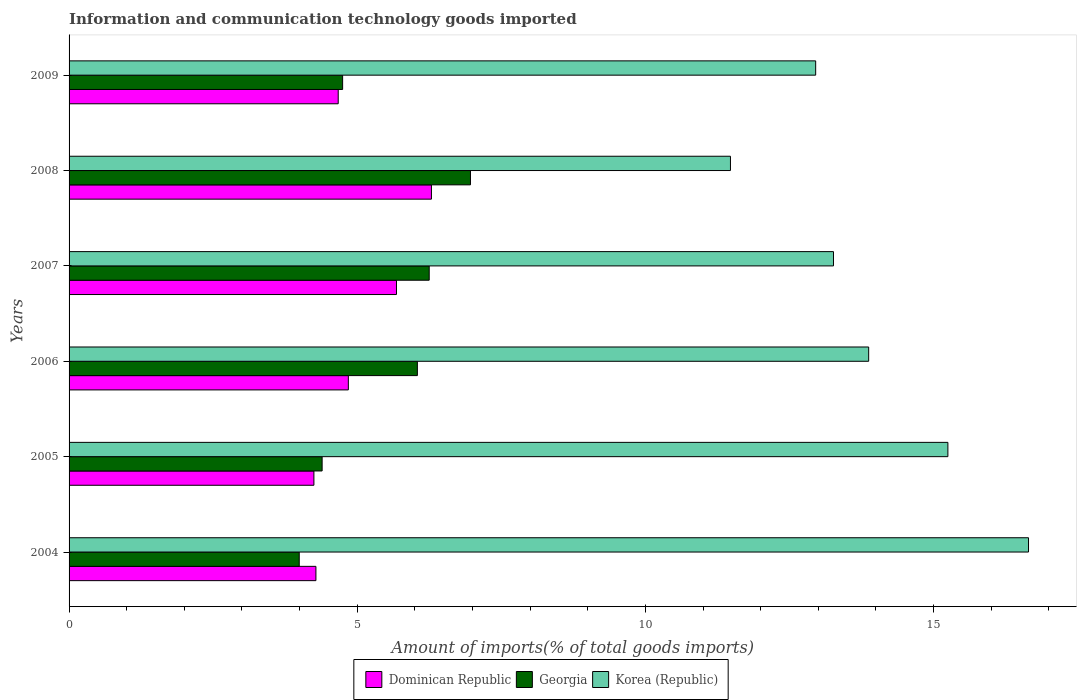How many groups of bars are there?
Ensure brevity in your answer.  6. Are the number of bars per tick equal to the number of legend labels?
Provide a short and direct response. Yes. What is the label of the 5th group of bars from the top?
Your answer should be compact. 2005. In how many cases, is the number of bars for a given year not equal to the number of legend labels?
Your answer should be very brief. 0. What is the amount of goods imported in Dominican Republic in 2005?
Provide a short and direct response. 4.25. Across all years, what is the maximum amount of goods imported in Korea (Republic)?
Give a very brief answer. 16.65. Across all years, what is the minimum amount of goods imported in Dominican Republic?
Give a very brief answer. 4.25. In which year was the amount of goods imported in Korea (Republic) maximum?
Give a very brief answer. 2004. In which year was the amount of goods imported in Dominican Republic minimum?
Ensure brevity in your answer.  2005. What is the total amount of goods imported in Korea (Republic) in the graph?
Ensure brevity in your answer.  83.47. What is the difference between the amount of goods imported in Georgia in 2006 and that in 2008?
Offer a very short reply. -0.92. What is the difference between the amount of goods imported in Dominican Republic in 2004 and the amount of goods imported in Korea (Republic) in 2008?
Make the answer very short. -7.19. What is the average amount of goods imported in Dominican Republic per year?
Offer a very short reply. 5. In the year 2008, what is the difference between the amount of goods imported in Korea (Republic) and amount of goods imported in Georgia?
Make the answer very short. 4.51. In how many years, is the amount of goods imported in Korea (Republic) greater than 10 %?
Your response must be concise. 6. What is the ratio of the amount of goods imported in Georgia in 2005 to that in 2007?
Give a very brief answer. 0.7. Is the amount of goods imported in Georgia in 2006 less than that in 2007?
Offer a very short reply. Yes. What is the difference between the highest and the second highest amount of goods imported in Dominican Republic?
Keep it short and to the point. 0.61. What is the difference between the highest and the lowest amount of goods imported in Dominican Republic?
Make the answer very short. 2.04. What does the 3rd bar from the top in 2008 represents?
Provide a succinct answer. Dominican Republic. Is it the case that in every year, the sum of the amount of goods imported in Georgia and amount of goods imported in Korea (Republic) is greater than the amount of goods imported in Dominican Republic?
Provide a short and direct response. Yes. How many bars are there?
Keep it short and to the point. 18. Are the values on the major ticks of X-axis written in scientific E-notation?
Offer a terse response. No. Does the graph contain any zero values?
Keep it short and to the point. No. Does the graph contain grids?
Give a very brief answer. No. Where does the legend appear in the graph?
Your answer should be very brief. Bottom center. How many legend labels are there?
Ensure brevity in your answer.  3. How are the legend labels stacked?
Give a very brief answer. Horizontal. What is the title of the graph?
Ensure brevity in your answer.  Information and communication technology goods imported. Does "Macao" appear as one of the legend labels in the graph?
Give a very brief answer. No. What is the label or title of the X-axis?
Your answer should be compact. Amount of imports(% of total goods imports). What is the label or title of the Y-axis?
Offer a very short reply. Years. What is the Amount of imports(% of total goods imports) in Dominican Republic in 2004?
Provide a short and direct response. 4.28. What is the Amount of imports(% of total goods imports) of Georgia in 2004?
Offer a terse response. 3.99. What is the Amount of imports(% of total goods imports) of Korea (Republic) in 2004?
Your answer should be very brief. 16.65. What is the Amount of imports(% of total goods imports) of Dominican Republic in 2005?
Offer a very short reply. 4.25. What is the Amount of imports(% of total goods imports) in Georgia in 2005?
Ensure brevity in your answer.  4.39. What is the Amount of imports(% of total goods imports) in Korea (Republic) in 2005?
Make the answer very short. 15.25. What is the Amount of imports(% of total goods imports) in Dominican Republic in 2006?
Ensure brevity in your answer.  4.85. What is the Amount of imports(% of total goods imports) in Georgia in 2006?
Keep it short and to the point. 6.04. What is the Amount of imports(% of total goods imports) of Korea (Republic) in 2006?
Keep it short and to the point. 13.87. What is the Amount of imports(% of total goods imports) of Dominican Republic in 2007?
Keep it short and to the point. 5.68. What is the Amount of imports(% of total goods imports) in Georgia in 2007?
Keep it short and to the point. 6.25. What is the Amount of imports(% of total goods imports) in Korea (Republic) in 2007?
Your response must be concise. 13.26. What is the Amount of imports(% of total goods imports) of Dominican Republic in 2008?
Keep it short and to the point. 6.29. What is the Amount of imports(% of total goods imports) of Georgia in 2008?
Provide a succinct answer. 6.96. What is the Amount of imports(% of total goods imports) of Korea (Republic) in 2008?
Make the answer very short. 11.48. What is the Amount of imports(% of total goods imports) of Dominican Republic in 2009?
Provide a short and direct response. 4.67. What is the Amount of imports(% of total goods imports) of Georgia in 2009?
Provide a succinct answer. 4.75. What is the Amount of imports(% of total goods imports) of Korea (Republic) in 2009?
Give a very brief answer. 12.95. Across all years, what is the maximum Amount of imports(% of total goods imports) in Dominican Republic?
Your answer should be very brief. 6.29. Across all years, what is the maximum Amount of imports(% of total goods imports) in Georgia?
Keep it short and to the point. 6.96. Across all years, what is the maximum Amount of imports(% of total goods imports) in Korea (Republic)?
Your response must be concise. 16.65. Across all years, what is the minimum Amount of imports(% of total goods imports) in Dominican Republic?
Your answer should be very brief. 4.25. Across all years, what is the minimum Amount of imports(% of total goods imports) of Georgia?
Provide a succinct answer. 3.99. Across all years, what is the minimum Amount of imports(% of total goods imports) in Korea (Republic)?
Keep it short and to the point. 11.48. What is the total Amount of imports(% of total goods imports) of Dominican Republic in the graph?
Offer a terse response. 30.02. What is the total Amount of imports(% of total goods imports) in Georgia in the graph?
Offer a terse response. 32.39. What is the total Amount of imports(% of total goods imports) in Korea (Republic) in the graph?
Your answer should be very brief. 83.47. What is the difference between the Amount of imports(% of total goods imports) of Dominican Republic in 2004 and that in 2005?
Offer a very short reply. 0.04. What is the difference between the Amount of imports(% of total goods imports) of Georgia in 2004 and that in 2005?
Offer a very short reply. -0.4. What is the difference between the Amount of imports(% of total goods imports) of Korea (Republic) in 2004 and that in 2005?
Give a very brief answer. 1.4. What is the difference between the Amount of imports(% of total goods imports) in Dominican Republic in 2004 and that in 2006?
Give a very brief answer. -0.56. What is the difference between the Amount of imports(% of total goods imports) of Georgia in 2004 and that in 2006?
Offer a very short reply. -2.05. What is the difference between the Amount of imports(% of total goods imports) in Korea (Republic) in 2004 and that in 2006?
Provide a succinct answer. 2.77. What is the difference between the Amount of imports(% of total goods imports) of Dominican Republic in 2004 and that in 2007?
Make the answer very short. -1.4. What is the difference between the Amount of imports(% of total goods imports) in Georgia in 2004 and that in 2007?
Your answer should be very brief. -2.26. What is the difference between the Amount of imports(% of total goods imports) of Korea (Republic) in 2004 and that in 2007?
Keep it short and to the point. 3.38. What is the difference between the Amount of imports(% of total goods imports) of Dominican Republic in 2004 and that in 2008?
Give a very brief answer. -2. What is the difference between the Amount of imports(% of total goods imports) in Georgia in 2004 and that in 2008?
Your answer should be compact. -2.97. What is the difference between the Amount of imports(% of total goods imports) in Korea (Republic) in 2004 and that in 2008?
Make the answer very short. 5.17. What is the difference between the Amount of imports(% of total goods imports) in Dominican Republic in 2004 and that in 2009?
Provide a succinct answer. -0.39. What is the difference between the Amount of imports(% of total goods imports) in Georgia in 2004 and that in 2009?
Keep it short and to the point. -0.75. What is the difference between the Amount of imports(% of total goods imports) of Korea (Republic) in 2004 and that in 2009?
Keep it short and to the point. 3.69. What is the difference between the Amount of imports(% of total goods imports) of Dominican Republic in 2005 and that in 2006?
Your response must be concise. -0.6. What is the difference between the Amount of imports(% of total goods imports) of Georgia in 2005 and that in 2006?
Offer a very short reply. -1.65. What is the difference between the Amount of imports(% of total goods imports) of Korea (Republic) in 2005 and that in 2006?
Offer a terse response. 1.37. What is the difference between the Amount of imports(% of total goods imports) in Dominican Republic in 2005 and that in 2007?
Keep it short and to the point. -1.43. What is the difference between the Amount of imports(% of total goods imports) in Georgia in 2005 and that in 2007?
Your answer should be compact. -1.86. What is the difference between the Amount of imports(% of total goods imports) of Korea (Republic) in 2005 and that in 2007?
Your response must be concise. 1.99. What is the difference between the Amount of imports(% of total goods imports) of Dominican Republic in 2005 and that in 2008?
Give a very brief answer. -2.04. What is the difference between the Amount of imports(% of total goods imports) of Georgia in 2005 and that in 2008?
Your answer should be compact. -2.57. What is the difference between the Amount of imports(% of total goods imports) of Korea (Republic) in 2005 and that in 2008?
Your response must be concise. 3.77. What is the difference between the Amount of imports(% of total goods imports) of Dominican Republic in 2005 and that in 2009?
Keep it short and to the point. -0.42. What is the difference between the Amount of imports(% of total goods imports) in Georgia in 2005 and that in 2009?
Offer a terse response. -0.36. What is the difference between the Amount of imports(% of total goods imports) in Korea (Republic) in 2005 and that in 2009?
Provide a short and direct response. 2.29. What is the difference between the Amount of imports(% of total goods imports) of Dominican Republic in 2006 and that in 2007?
Your answer should be very brief. -0.84. What is the difference between the Amount of imports(% of total goods imports) of Georgia in 2006 and that in 2007?
Give a very brief answer. -0.21. What is the difference between the Amount of imports(% of total goods imports) in Korea (Republic) in 2006 and that in 2007?
Offer a terse response. 0.61. What is the difference between the Amount of imports(% of total goods imports) of Dominican Republic in 2006 and that in 2008?
Make the answer very short. -1.44. What is the difference between the Amount of imports(% of total goods imports) in Georgia in 2006 and that in 2008?
Make the answer very short. -0.92. What is the difference between the Amount of imports(% of total goods imports) of Korea (Republic) in 2006 and that in 2008?
Offer a very short reply. 2.4. What is the difference between the Amount of imports(% of total goods imports) in Dominican Republic in 2006 and that in 2009?
Your response must be concise. 0.18. What is the difference between the Amount of imports(% of total goods imports) of Georgia in 2006 and that in 2009?
Give a very brief answer. 1.3. What is the difference between the Amount of imports(% of total goods imports) in Korea (Republic) in 2006 and that in 2009?
Your response must be concise. 0.92. What is the difference between the Amount of imports(% of total goods imports) of Dominican Republic in 2007 and that in 2008?
Offer a very short reply. -0.61. What is the difference between the Amount of imports(% of total goods imports) in Georgia in 2007 and that in 2008?
Provide a short and direct response. -0.72. What is the difference between the Amount of imports(% of total goods imports) of Korea (Republic) in 2007 and that in 2008?
Give a very brief answer. 1.79. What is the difference between the Amount of imports(% of total goods imports) of Dominican Republic in 2007 and that in 2009?
Your answer should be very brief. 1.01. What is the difference between the Amount of imports(% of total goods imports) in Georgia in 2007 and that in 2009?
Provide a succinct answer. 1.5. What is the difference between the Amount of imports(% of total goods imports) in Korea (Republic) in 2007 and that in 2009?
Offer a terse response. 0.31. What is the difference between the Amount of imports(% of total goods imports) in Dominican Republic in 2008 and that in 2009?
Your response must be concise. 1.62. What is the difference between the Amount of imports(% of total goods imports) of Georgia in 2008 and that in 2009?
Give a very brief answer. 2.22. What is the difference between the Amount of imports(% of total goods imports) of Korea (Republic) in 2008 and that in 2009?
Ensure brevity in your answer.  -1.48. What is the difference between the Amount of imports(% of total goods imports) of Dominican Republic in 2004 and the Amount of imports(% of total goods imports) of Georgia in 2005?
Provide a succinct answer. -0.11. What is the difference between the Amount of imports(% of total goods imports) of Dominican Republic in 2004 and the Amount of imports(% of total goods imports) of Korea (Republic) in 2005?
Your response must be concise. -10.97. What is the difference between the Amount of imports(% of total goods imports) in Georgia in 2004 and the Amount of imports(% of total goods imports) in Korea (Republic) in 2005?
Make the answer very short. -11.26. What is the difference between the Amount of imports(% of total goods imports) of Dominican Republic in 2004 and the Amount of imports(% of total goods imports) of Georgia in 2006?
Offer a very short reply. -1.76. What is the difference between the Amount of imports(% of total goods imports) of Dominican Republic in 2004 and the Amount of imports(% of total goods imports) of Korea (Republic) in 2006?
Offer a very short reply. -9.59. What is the difference between the Amount of imports(% of total goods imports) in Georgia in 2004 and the Amount of imports(% of total goods imports) in Korea (Republic) in 2006?
Make the answer very short. -9.88. What is the difference between the Amount of imports(% of total goods imports) of Dominican Republic in 2004 and the Amount of imports(% of total goods imports) of Georgia in 2007?
Make the answer very short. -1.97. What is the difference between the Amount of imports(% of total goods imports) in Dominican Republic in 2004 and the Amount of imports(% of total goods imports) in Korea (Republic) in 2007?
Offer a very short reply. -8.98. What is the difference between the Amount of imports(% of total goods imports) in Georgia in 2004 and the Amount of imports(% of total goods imports) in Korea (Republic) in 2007?
Your response must be concise. -9.27. What is the difference between the Amount of imports(% of total goods imports) of Dominican Republic in 2004 and the Amount of imports(% of total goods imports) of Georgia in 2008?
Your answer should be very brief. -2.68. What is the difference between the Amount of imports(% of total goods imports) of Dominican Republic in 2004 and the Amount of imports(% of total goods imports) of Korea (Republic) in 2008?
Ensure brevity in your answer.  -7.19. What is the difference between the Amount of imports(% of total goods imports) in Georgia in 2004 and the Amount of imports(% of total goods imports) in Korea (Republic) in 2008?
Provide a succinct answer. -7.48. What is the difference between the Amount of imports(% of total goods imports) of Dominican Republic in 2004 and the Amount of imports(% of total goods imports) of Georgia in 2009?
Make the answer very short. -0.46. What is the difference between the Amount of imports(% of total goods imports) of Dominican Republic in 2004 and the Amount of imports(% of total goods imports) of Korea (Republic) in 2009?
Make the answer very short. -8.67. What is the difference between the Amount of imports(% of total goods imports) in Georgia in 2004 and the Amount of imports(% of total goods imports) in Korea (Republic) in 2009?
Keep it short and to the point. -8.96. What is the difference between the Amount of imports(% of total goods imports) of Dominican Republic in 2005 and the Amount of imports(% of total goods imports) of Georgia in 2006?
Ensure brevity in your answer.  -1.8. What is the difference between the Amount of imports(% of total goods imports) in Dominican Republic in 2005 and the Amount of imports(% of total goods imports) in Korea (Republic) in 2006?
Offer a terse response. -9.63. What is the difference between the Amount of imports(% of total goods imports) of Georgia in 2005 and the Amount of imports(% of total goods imports) of Korea (Republic) in 2006?
Offer a terse response. -9.48. What is the difference between the Amount of imports(% of total goods imports) in Dominican Republic in 2005 and the Amount of imports(% of total goods imports) in Georgia in 2007?
Offer a terse response. -2. What is the difference between the Amount of imports(% of total goods imports) of Dominican Republic in 2005 and the Amount of imports(% of total goods imports) of Korea (Republic) in 2007?
Offer a very short reply. -9.02. What is the difference between the Amount of imports(% of total goods imports) of Georgia in 2005 and the Amount of imports(% of total goods imports) of Korea (Republic) in 2007?
Your answer should be very brief. -8.87. What is the difference between the Amount of imports(% of total goods imports) in Dominican Republic in 2005 and the Amount of imports(% of total goods imports) in Georgia in 2008?
Your response must be concise. -2.72. What is the difference between the Amount of imports(% of total goods imports) of Dominican Republic in 2005 and the Amount of imports(% of total goods imports) of Korea (Republic) in 2008?
Your answer should be compact. -7.23. What is the difference between the Amount of imports(% of total goods imports) of Georgia in 2005 and the Amount of imports(% of total goods imports) of Korea (Republic) in 2008?
Offer a terse response. -7.09. What is the difference between the Amount of imports(% of total goods imports) of Dominican Republic in 2005 and the Amount of imports(% of total goods imports) of Georgia in 2009?
Make the answer very short. -0.5. What is the difference between the Amount of imports(% of total goods imports) in Dominican Republic in 2005 and the Amount of imports(% of total goods imports) in Korea (Republic) in 2009?
Your answer should be very brief. -8.71. What is the difference between the Amount of imports(% of total goods imports) in Georgia in 2005 and the Amount of imports(% of total goods imports) in Korea (Republic) in 2009?
Make the answer very short. -8.56. What is the difference between the Amount of imports(% of total goods imports) of Dominican Republic in 2006 and the Amount of imports(% of total goods imports) of Georgia in 2007?
Ensure brevity in your answer.  -1.4. What is the difference between the Amount of imports(% of total goods imports) of Dominican Republic in 2006 and the Amount of imports(% of total goods imports) of Korea (Republic) in 2007?
Offer a very short reply. -8.42. What is the difference between the Amount of imports(% of total goods imports) of Georgia in 2006 and the Amount of imports(% of total goods imports) of Korea (Republic) in 2007?
Ensure brevity in your answer.  -7.22. What is the difference between the Amount of imports(% of total goods imports) in Dominican Republic in 2006 and the Amount of imports(% of total goods imports) in Georgia in 2008?
Your answer should be compact. -2.12. What is the difference between the Amount of imports(% of total goods imports) of Dominican Republic in 2006 and the Amount of imports(% of total goods imports) of Korea (Republic) in 2008?
Your response must be concise. -6.63. What is the difference between the Amount of imports(% of total goods imports) of Georgia in 2006 and the Amount of imports(% of total goods imports) of Korea (Republic) in 2008?
Your answer should be compact. -5.43. What is the difference between the Amount of imports(% of total goods imports) in Dominican Republic in 2006 and the Amount of imports(% of total goods imports) in Georgia in 2009?
Keep it short and to the point. 0.1. What is the difference between the Amount of imports(% of total goods imports) in Dominican Republic in 2006 and the Amount of imports(% of total goods imports) in Korea (Republic) in 2009?
Your response must be concise. -8.11. What is the difference between the Amount of imports(% of total goods imports) in Georgia in 2006 and the Amount of imports(% of total goods imports) in Korea (Republic) in 2009?
Make the answer very short. -6.91. What is the difference between the Amount of imports(% of total goods imports) of Dominican Republic in 2007 and the Amount of imports(% of total goods imports) of Georgia in 2008?
Offer a very short reply. -1.28. What is the difference between the Amount of imports(% of total goods imports) of Dominican Republic in 2007 and the Amount of imports(% of total goods imports) of Korea (Republic) in 2008?
Give a very brief answer. -5.8. What is the difference between the Amount of imports(% of total goods imports) of Georgia in 2007 and the Amount of imports(% of total goods imports) of Korea (Republic) in 2008?
Offer a terse response. -5.23. What is the difference between the Amount of imports(% of total goods imports) of Dominican Republic in 2007 and the Amount of imports(% of total goods imports) of Georgia in 2009?
Keep it short and to the point. 0.93. What is the difference between the Amount of imports(% of total goods imports) in Dominican Republic in 2007 and the Amount of imports(% of total goods imports) in Korea (Republic) in 2009?
Make the answer very short. -7.27. What is the difference between the Amount of imports(% of total goods imports) of Georgia in 2007 and the Amount of imports(% of total goods imports) of Korea (Republic) in 2009?
Provide a succinct answer. -6.71. What is the difference between the Amount of imports(% of total goods imports) in Dominican Republic in 2008 and the Amount of imports(% of total goods imports) in Georgia in 2009?
Keep it short and to the point. 1.54. What is the difference between the Amount of imports(% of total goods imports) of Dominican Republic in 2008 and the Amount of imports(% of total goods imports) of Korea (Republic) in 2009?
Make the answer very short. -6.67. What is the difference between the Amount of imports(% of total goods imports) in Georgia in 2008 and the Amount of imports(% of total goods imports) in Korea (Republic) in 2009?
Provide a short and direct response. -5.99. What is the average Amount of imports(% of total goods imports) of Dominican Republic per year?
Ensure brevity in your answer.  5. What is the average Amount of imports(% of total goods imports) of Georgia per year?
Make the answer very short. 5.4. What is the average Amount of imports(% of total goods imports) of Korea (Republic) per year?
Make the answer very short. 13.91. In the year 2004, what is the difference between the Amount of imports(% of total goods imports) in Dominican Republic and Amount of imports(% of total goods imports) in Georgia?
Ensure brevity in your answer.  0.29. In the year 2004, what is the difference between the Amount of imports(% of total goods imports) of Dominican Republic and Amount of imports(% of total goods imports) of Korea (Republic)?
Offer a very short reply. -12.36. In the year 2004, what is the difference between the Amount of imports(% of total goods imports) of Georgia and Amount of imports(% of total goods imports) of Korea (Republic)?
Your response must be concise. -12.65. In the year 2005, what is the difference between the Amount of imports(% of total goods imports) in Dominican Republic and Amount of imports(% of total goods imports) in Georgia?
Make the answer very short. -0.14. In the year 2005, what is the difference between the Amount of imports(% of total goods imports) of Dominican Republic and Amount of imports(% of total goods imports) of Korea (Republic)?
Ensure brevity in your answer.  -11. In the year 2005, what is the difference between the Amount of imports(% of total goods imports) in Georgia and Amount of imports(% of total goods imports) in Korea (Republic)?
Your response must be concise. -10.86. In the year 2006, what is the difference between the Amount of imports(% of total goods imports) in Dominican Republic and Amount of imports(% of total goods imports) in Georgia?
Provide a short and direct response. -1.2. In the year 2006, what is the difference between the Amount of imports(% of total goods imports) in Dominican Republic and Amount of imports(% of total goods imports) in Korea (Republic)?
Your answer should be very brief. -9.03. In the year 2006, what is the difference between the Amount of imports(% of total goods imports) of Georgia and Amount of imports(% of total goods imports) of Korea (Republic)?
Ensure brevity in your answer.  -7.83. In the year 2007, what is the difference between the Amount of imports(% of total goods imports) in Dominican Republic and Amount of imports(% of total goods imports) in Georgia?
Offer a very short reply. -0.57. In the year 2007, what is the difference between the Amount of imports(% of total goods imports) in Dominican Republic and Amount of imports(% of total goods imports) in Korea (Republic)?
Make the answer very short. -7.58. In the year 2007, what is the difference between the Amount of imports(% of total goods imports) of Georgia and Amount of imports(% of total goods imports) of Korea (Republic)?
Ensure brevity in your answer.  -7.01. In the year 2008, what is the difference between the Amount of imports(% of total goods imports) of Dominican Republic and Amount of imports(% of total goods imports) of Georgia?
Ensure brevity in your answer.  -0.68. In the year 2008, what is the difference between the Amount of imports(% of total goods imports) in Dominican Republic and Amount of imports(% of total goods imports) in Korea (Republic)?
Provide a short and direct response. -5.19. In the year 2008, what is the difference between the Amount of imports(% of total goods imports) in Georgia and Amount of imports(% of total goods imports) in Korea (Republic)?
Give a very brief answer. -4.51. In the year 2009, what is the difference between the Amount of imports(% of total goods imports) of Dominican Republic and Amount of imports(% of total goods imports) of Georgia?
Your answer should be compact. -0.08. In the year 2009, what is the difference between the Amount of imports(% of total goods imports) of Dominican Republic and Amount of imports(% of total goods imports) of Korea (Republic)?
Provide a succinct answer. -8.28. In the year 2009, what is the difference between the Amount of imports(% of total goods imports) in Georgia and Amount of imports(% of total goods imports) in Korea (Republic)?
Keep it short and to the point. -8.21. What is the ratio of the Amount of imports(% of total goods imports) in Dominican Republic in 2004 to that in 2005?
Your response must be concise. 1.01. What is the ratio of the Amount of imports(% of total goods imports) in Georgia in 2004 to that in 2005?
Provide a succinct answer. 0.91. What is the ratio of the Amount of imports(% of total goods imports) in Korea (Republic) in 2004 to that in 2005?
Make the answer very short. 1.09. What is the ratio of the Amount of imports(% of total goods imports) of Dominican Republic in 2004 to that in 2006?
Your answer should be compact. 0.88. What is the ratio of the Amount of imports(% of total goods imports) in Georgia in 2004 to that in 2006?
Give a very brief answer. 0.66. What is the ratio of the Amount of imports(% of total goods imports) in Korea (Republic) in 2004 to that in 2006?
Your answer should be compact. 1.2. What is the ratio of the Amount of imports(% of total goods imports) of Dominican Republic in 2004 to that in 2007?
Your response must be concise. 0.75. What is the ratio of the Amount of imports(% of total goods imports) in Georgia in 2004 to that in 2007?
Provide a succinct answer. 0.64. What is the ratio of the Amount of imports(% of total goods imports) in Korea (Republic) in 2004 to that in 2007?
Your answer should be very brief. 1.26. What is the ratio of the Amount of imports(% of total goods imports) in Dominican Republic in 2004 to that in 2008?
Your answer should be compact. 0.68. What is the ratio of the Amount of imports(% of total goods imports) of Georgia in 2004 to that in 2008?
Give a very brief answer. 0.57. What is the ratio of the Amount of imports(% of total goods imports) of Korea (Republic) in 2004 to that in 2008?
Ensure brevity in your answer.  1.45. What is the ratio of the Amount of imports(% of total goods imports) in Dominican Republic in 2004 to that in 2009?
Your answer should be compact. 0.92. What is the ratio of the Amount of imports(% of total goods imports) of Georgia in 2004 to that in 2009?
Ensure brevity in your answer.  0.84. What is the ratio of the Amount of imports(% of total goods imports) of Korea (Republic) in 2004 to that in 2009?
Your answer should be compact. 1.29. What is the ratio of the Amount of imports(% of total goods imports) of Dominican Republic in 2005 to that in 2006?
Offer a very short reply. 0.88. What is the ratio of the Amount of imports(% of total goods imports) of Georgia in 2005 to that in 2006?
Your answer should be compact. 0.73. What is the ratio of the Amount of imports(% of total goods imports) of Korea (Republic) in 2005 to that in 2006?
Offer a very short reply. 1.1. What is the ratio of the Amount of imports(% of total goods imports) of Dominican Republic in 2005 to that in 2007?
Offer a very short reply. 0.75. What is the ratio of the Amount of imports(% of total goods imports) in Georgia in 2005 to that in 2007?
Give a very brief answer. 0.7. What is the ratio of the Amount of imports(% of total goods imports) of Korea (Republic) in 2005 to that in 2007?
Make the answer very short. 1.15. What is the ratio of the Amount of imports(% of total goods imports) in Dominican Republic in 2005 to that in 2008?
Your answer should be compact. 0.68. What is the ratio of the Amount of imports(% of total goods imports) of Georgia in 2005 to that in 2008?
Your answer should be compact. 0.63. What is the ratio of the Amount of imports(% of total goods imports) in Korea (Republic) in 2005 to that in 2008?
Ensure brevity in your answer.  1.33. What is the ratio of the Amount of imports(% of total goods imports) of Dominican Republic in 2005 to that in 2009?
Offer a terse response. 0.91. What is the ratio of the Amount of imports(% of total goods imports) in Georgia in 2005 to that in 2009?
Ensure brevity in your answer.  0.93. What is the ratio of the Amount of imports(% of total goods imports) of Korea (Republic) in 2005 to that in 2009?
Keep it short and to the point. 1.18. What is the ratio of the Amount of imports(% of total goods imports) of Dominican Republic in 2006 to that in 2007?
Provide a succinct answer. 0.85. What is the ratio of the Amount of imports(% of total goods imports) of Georgia in 2006 to that in 2007?
Your response must be concise. 0.97. What is the ratio of the Amount of imports(% of total goods imports) in Korea (Republic) in 2006 to that in 2007?
Give a very brief answer. 1.05. What is the ratio of the Amount of imports(% of total goods imports) in Dominican Republic in 2006 to that in 2008?
Provide a succinct answer. 0.77. What is the ratio of the Amount of imports(% of total goods imports) in Georgia in 2006 to that in 2008?
Offer a terse response. 0.87. What is the ratio of the Amount of imports(% of total goods imports) of Korea (Republic) in 2006 to that in 2008?
Give a very brief answer. 1.21. What is the ratio of the Amount of imports(% of total goods imports) in Dominican Republic in 2006 to that in 2009?
Offer a very short reply. 1.04. What is the ratio of the Amount of imports(% of total goods imports) in Georgia in 2006 to that in 2009?
Ensure brevity in your answer.  1.27. What is the ratio of the Amount of imports(% of total goods imports) in Korea (Republic) in 2006 to that in 2009?
Make the answer very short. 1.07. What is the ratio of the Amount of imports(% of total goods imports) of Dominican Republic in 2007 to that in 2008?
Your response must be concise. 0.9. What is the ratio of the Amount of imports(% of total goods imports) of Georgia in 2007 to that in 2008?
Provide a short and direct response. 0.9. What is the ratio of the Amount of imports(% of total goods imports) of Korea (Republic) in 2007 to that in 2008?
Offer a very short reply. 1.16. What is the ratio of the Amount of imports(% of total goods imports) of Dominican Republic in 2007 to that in 2009?
Your answer should be compact. 1.22. What is the ratio of the Amount of imports(% of total goods imports) of Georgia in 2007 to that in 2009?
Your answer should be very brief. 1.32. What is the ratio of the Amount of imports(% of total goods imports) in Korea (Republic) in 2007 to that in 2009?
Give a very brief answer. 1.02. What is the ratio of the Amount of imports(% of total goods imports) in Dominican Republic in 2008 to that in 2009?
Give a very brief answer. 1.35. What is the ratio of the Amount of imports(% of total goods imports) of Georgia in 2008 to that in 2009?
Your answer should be very brief. 1.47. What is the ratio of the Amount of imports(% of total goods imports) in Korea (Republic) in 2008 to that in 2009?
Offer a very short reply. 0.89. What is the difference between the highest and the second highest Amount of imports(% of total goods imports) in Dominican Republic?
Your answer should be very brief. 0.61. What is the difference between the highest and the second highest Amount of imports(% of total goods imports) of Georgia?
Provide a short and direct response. 0.72. What is the difference between the highest and the second highest Amount of imports(% of total goods imports) of Korea (Republic)?
Keep it short and to the point. 1.4. What is the difference between the highest and the lowest Amount of imports(% of total goods imports) of Dominican Republic?
Offer a very short reply. 2.04. What is the difference between the highest and the lowest Amount of imports(% of total goods imports) of Georgia?
Provide a short and direct response. 2.97. What is the difference between the highest and the lowest Amount of imports(% of total goods imports) of Korea (Republic)?
Ensure brevity in your answer.  5.17. 